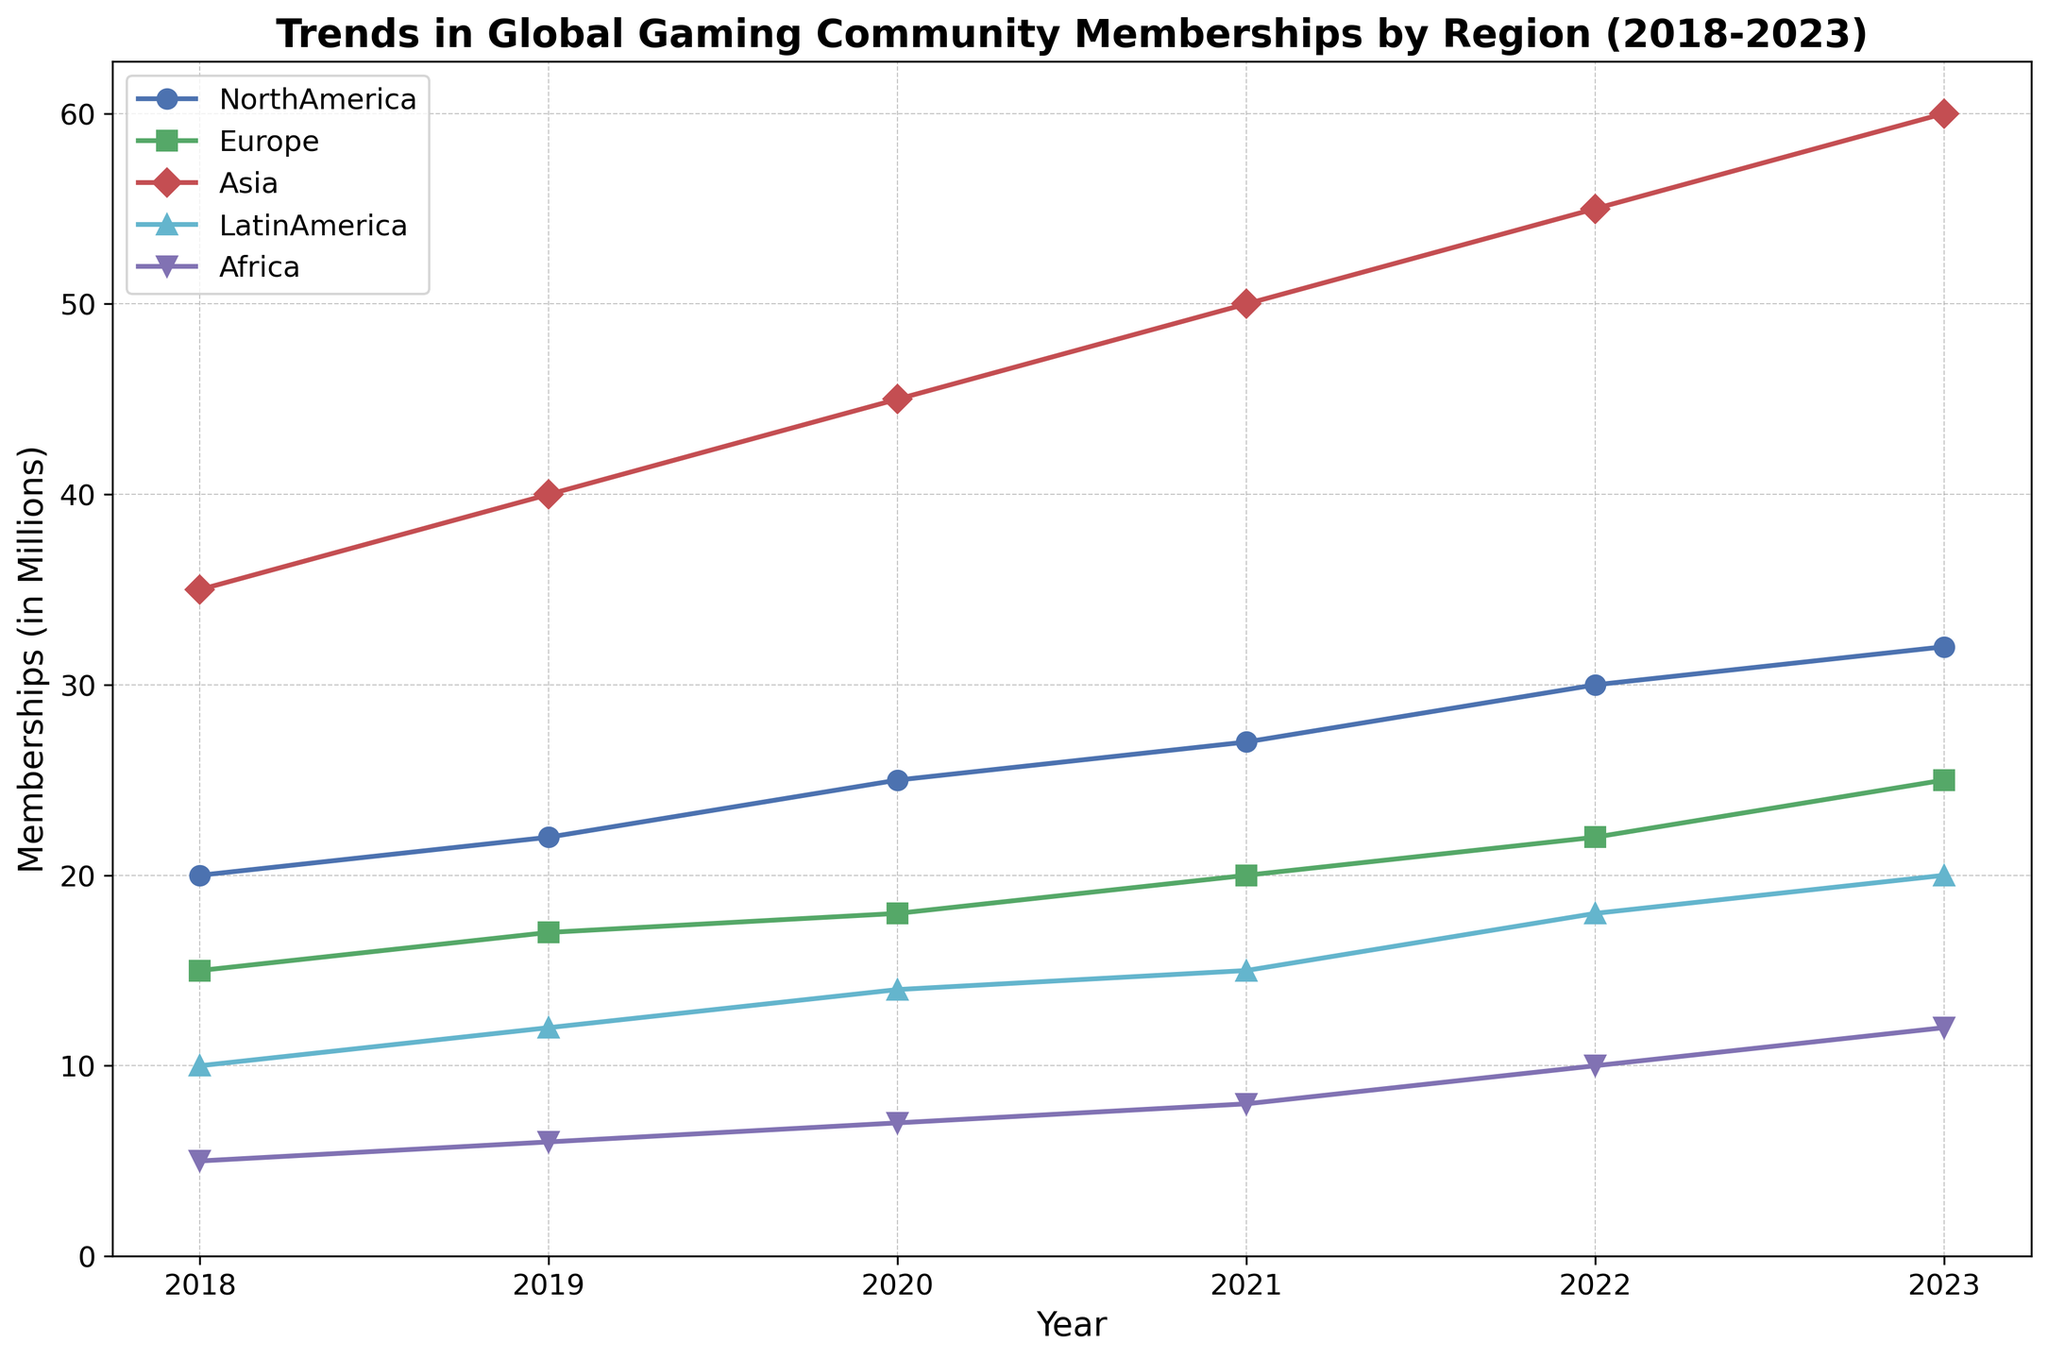What color represents the Asia region? By looking at the visual attributes, each region is marked with a specific color. The line representing Asia is marked in red.
Answer: Red Between which years did North America see its highest growth in memberships? To find the highest growth, we examine the differences between consecutive years. North America grew from 27 million memberships in 2021 to 30 million in 2022, which is a growth of 3 million, the highest among the years.
Answer: 2021-2022 Which region showed the most consistent growth over the 5 years? Consistent growth can be identified by regular and gradual increments in membership. Upon inspection, Asia's line graph exhibits a steady increase every year without any irregularities or sudden jumps.
Answer: Asia What is the total increase in memberships for North America from 2018 to 2023? To calculate the total increase, subtract the 2018 value from the 2023 value for North America: 32 million (2023) - 20 million (2018) = 12 million.
Answer: 12 million How did Europe’s membership growth between 2018 to 2023 compare to Asia’s? Europe grew from 15 million to 25 million, an increase of 10 million. Asia grew from 35 million to 60 million, an increase of 25 million. Comparing these values, Asia's increase is more significant.
Answer: Asia's growth is larger What is the combined membership of Latin America and Africa in 2023? Combine the 2023 values for Latin America and Africa: 20 million (Latin America) + 12 million (Africa) = 32 million.
Answer: 32 million Which year did Europe surpass 20 million memberships? Observe the data points on the graph for Europe. Europe reaches and surpasses 20 million memberships in 2021.
Answer: 2021 In 2020, which region had the least memberships and how many did they have? By checking the data points for all regions in 2020, Africa had the fewest memberships at 7 million.
Answer: Africa, 7 million What’s the average annual growth rate of the Asia region from 2018 to 2023? The growth over 5 years is 60 million - 35 million = 25 million. Average annual growth rate = 25 million / 5 years = 5 million per year.
Answer: 5 million per year 